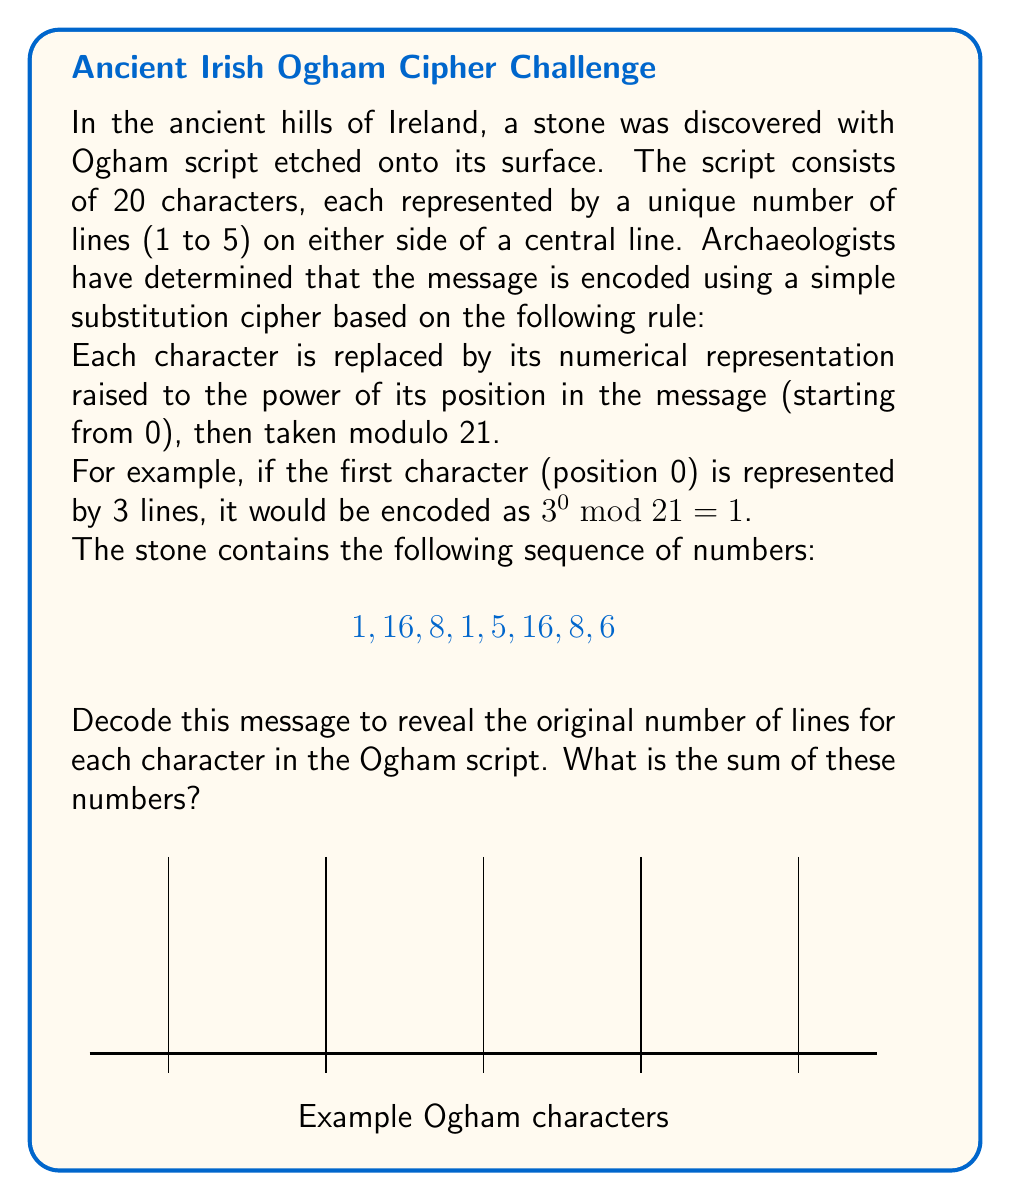What is the answer to this math problem? Let's approach this step-by-step:

1) We need to find the original number of lines for each character. Let's call these numbers $a, b, c, d, e, f, g, h$.

2) According to the encoding rule, we have:

   $a^0 \bmod 21 = 1$
   $b^1 \bmod 21 = 16$
   $c^2 \bmod 21 = 8$
   $d^3 \bmod 21 = 1$
   $e^4 \bmod 21 = 5$
   $f^5 \bmod 21 = 16$
   $g^6 \bmod 21 = 8$
   $h^7 \bmod 21 = 6$

3) Let's solve each equation:

   For $a$: Any number to the power of 0 is 1, so $a = 1, 2, 3, 4,$ or $5$.
   
   For $b$: We need to find $b$ such that $b^1 \equiv 16 \pmod{21}$. The only solution is $b = 16$.
   
   For $c$: We need to find $c$ such that $c^2 \equiv 8 \pmod{21}$. The solution is $c = 5$.
   
   For $d$: We need to find $d$ such that $d^3 \equiv 1 \pmod{21}$. The solution is $d = 1$.
   
   For $e$: We need to find $e$ such that $e^4 \equiv 5 \pmod{21}$. The solution is $e = 5$.
   
   For $f$: We need to find $f$ such that $f^5 \equiv 16 \pmod{21}$. The solution is $f = 2$.
   
   For $g$: We need to find $g$ such that $g^6 \equiv 8 \pmod{21}$. The solution is $g = 2$.
   
   For $h$: We need to find $h$ such that $h^7 \equiv 6 \pmod{21}$. The solution is $h = 3$.

4) Now we have the original numbers: 1, 16, 5, 1, 5, 2, 2, 3

5) The sum of these numbers is 1 + 16 + 5 + 1 + 5 + 2 + 2 + 3 = 35

Therefore, the sum of the original number of lines for each character in the Ogham script is 35.
Answer: 35 